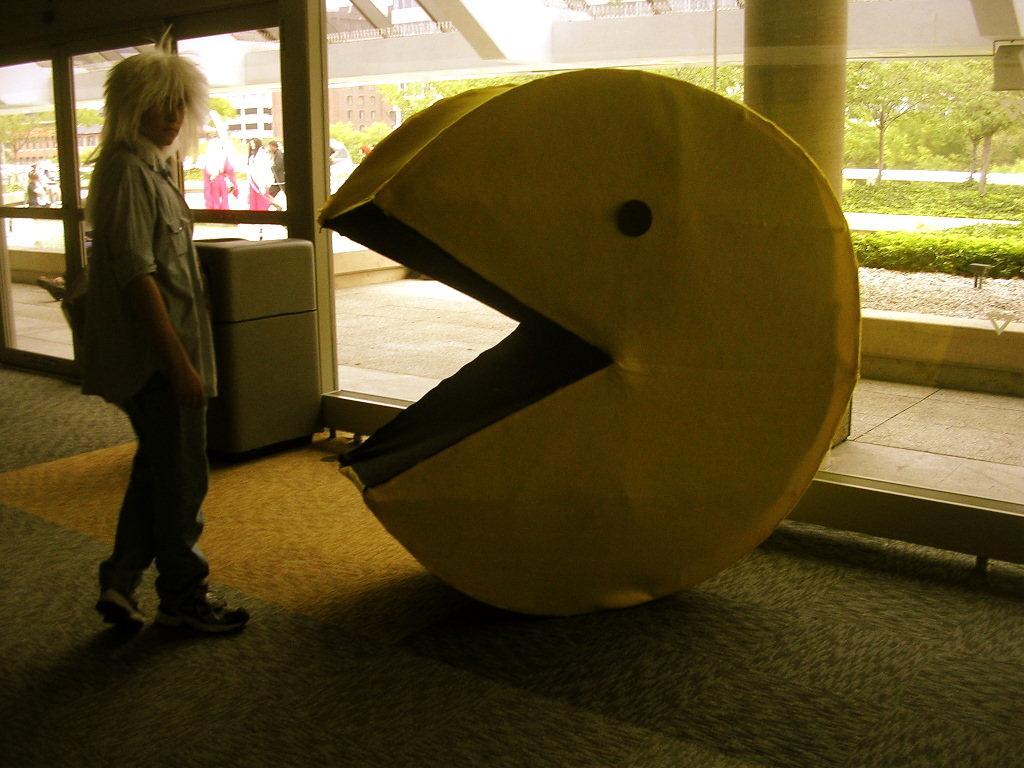Please provide a concise description of this image. In this image I can see the person with the dress. In-front of the person I can see some object. In the background I can see few more people, many trees and the buildings. 